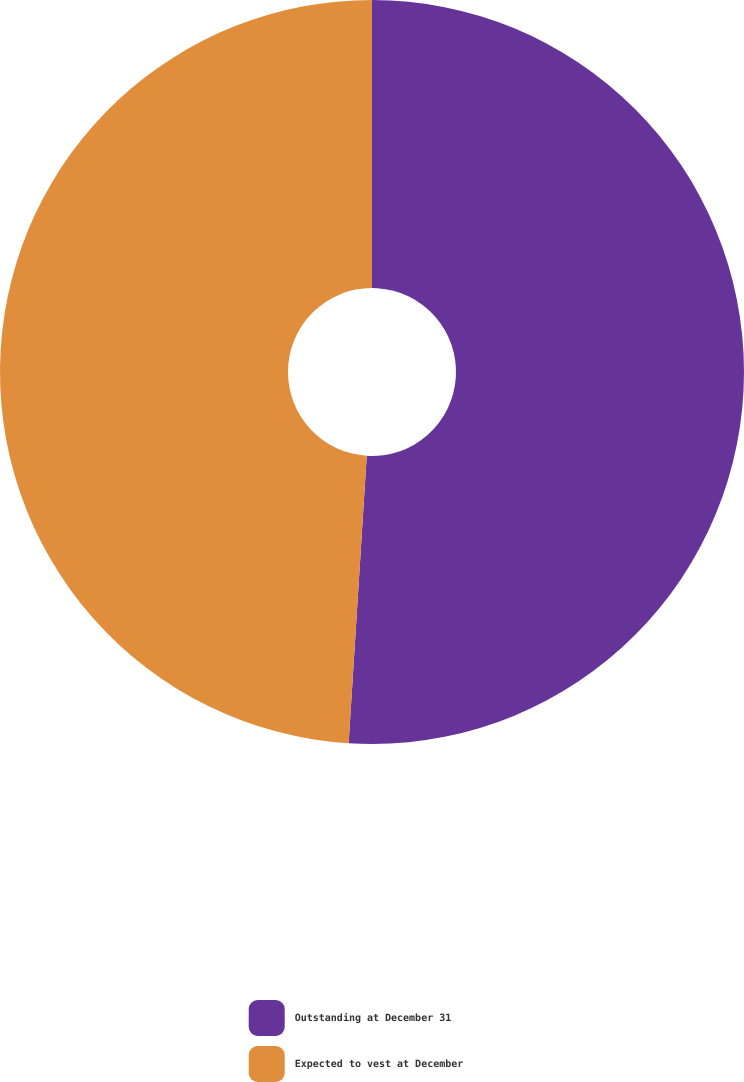<chart> <loc_0><loc_0><loc_500><loc_500><pie_chart><fcel>Outstanding at December 31<fcel>Expected to vest at December<nl><fcel>51.0%<fcel>49.0%<nl></chart> 